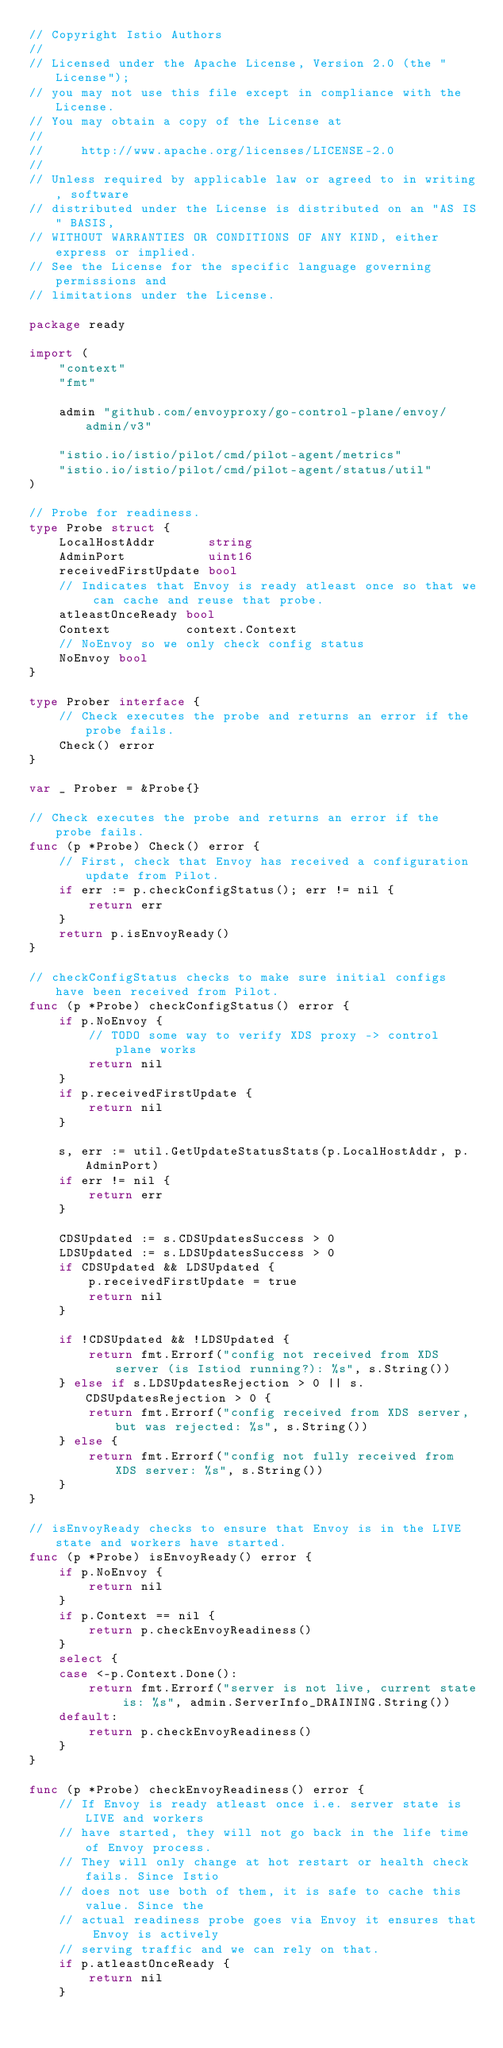Convert code to text. <code><loc_0><loc_0><loc_500><loc_500><_Go_>// Copyright Istio Authors
//
// Licensed under the Apache License, Version 2.0 (the "License");
// you may not use this file except in compliance with the License.
// You may obtain a copy of the License at
//
//     http://www.apache.org/licenses/LICENSE-2.0
//
// Unless required by applicable law or agreed to in writing, software
// distributed under the License is distributed on an "AS IS" BASIS,
// WITHOUT WARRANTIES OR CONDITIONS OF ANY KIND, either express or implied.
// See the License for the specific language governing permissions and
// limitations under the License.

package ready

import (
	"context"
	"fmt"

	admin "github.com/envoyproxy/go-control-plane/envoy/admin/v3"

	"istio.io/istio/pilot/cmd/pilot-agent/metrics"
	"istio.io/istio/pilot/cmd/pilot-agent/status/util"
)

// Probe for readiness.
type Probe struct {
	LocalHostAddr       string
	AdminPort           uint16
	receivedFirstUpdate bool
	// Indicates that Envoy is ready atleast once so that we can cache and reuse that probe.
	atleastOnceReady bool
	Context          context.Context
	// NoEnvoy so we only check config status
	NoEnvoy bool
}

type Prober interface {
	// Check executes the probe and returns an error if the probe fails.
	Check() error
}

var _ Prober = &Probe{}

// Check executes the probe and returns an error if the probe fails.
func (p *Probe) Check() error {
	// First, check that Envoy has received a configuration update from Pilot.
	if err := p.checkConfigStatus(); err != nil {
		return err
	}
	return p.isEnvoyReady()
}

// checkConfigStatus checks to make sure initial configs have been received from Pilot.
func (p *Probe) checkConfigStatus() error {
	if p.NoEnvoy {
		// TODO some way to verify XDS proxy -> control plane works
		return nil
	}
	if p.receivedFirstUpdate {
		return nil
	}

	s, err := util.GetUpdateStatusStats(p.LocalHostAddr, p.AdminPort)
	if err != nil {
		return err
	}

	CDSUpdated := s.CDSUpdatesSuccess > 0
	LDSUpdated := s.LDSUpdatesSuccess > 0
	if CDSUpdated && LDSUpdated {
		p.receivedFirstUpdate = true
		return nil
	}

	if !CDSUpdated && !LDSUpdated {
		return fmt.Errorf("config not received from XDS server (is Istiod running?): %s", s.String())
	} else if s.LDSUpdatesRejection > 0 || s.CDSUpdatesRejection > 0 {
		return fmt.Errorf("config received from XDS server, but was rejected: %s", s.String())
	} else {
		return fmt.Errorf("config not fully received from XDS server: %s", s.String())
	}
}

// isEnvoyReady checks to ensure that Envoy is in the LIVE state and workers have started.
func (p *Probe) isEnvoyReady() error {
	if p.NoEnvoy {
		return nil
	}
	if p.Context == nil {
		return p.checkEnvoyReadiness()
	}
	select {
	case <-p.Context.Done():
		return fmt.Errorf("server is not live, current state is: %s", admin.ServerInfo_DRAINING.String())
	default:
		return p.checkEnvoyReadiness()
	}
}

func (p *Probe) checkEnvoyReadiness() error {
	// If Envoy is ready atleast once i.e. server state is LIVE and workers
	// have started, they will not go back in the life time of Envoy process.
	// They will only change at hot restart or health check fails. Since Istio
	// does not use both of them, it is safe to cache this value. Since the
	// actual readiness probe goes via Envoy it ensures that Envoy is actively
	// serving traffic and we can rely on that.
	if p.atleastOnceReady {
		return nil
	}
</code> 